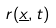<formula> <loc_0><loc_0><loc_500><loc_500>r ( \underline { x } , t )</formula> 